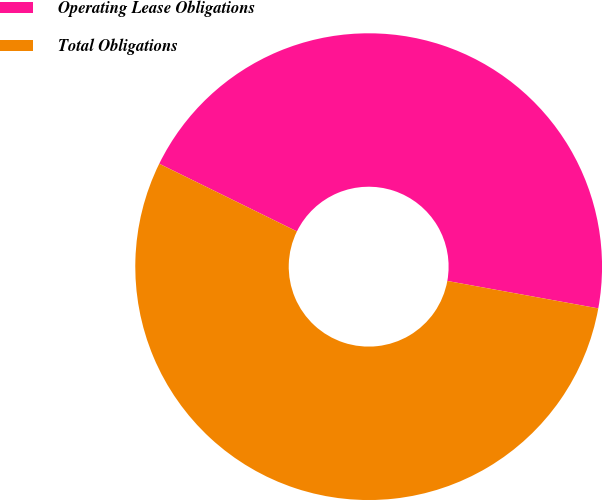Convert chart. <chart><loc_0><loc_0><loc_500><loc_500><pie_chart><fcel>Operating Lease Obligations<fcel>Total Obligations<nl><fcel>45.59%<fcel>54.41%<nl></chart> 